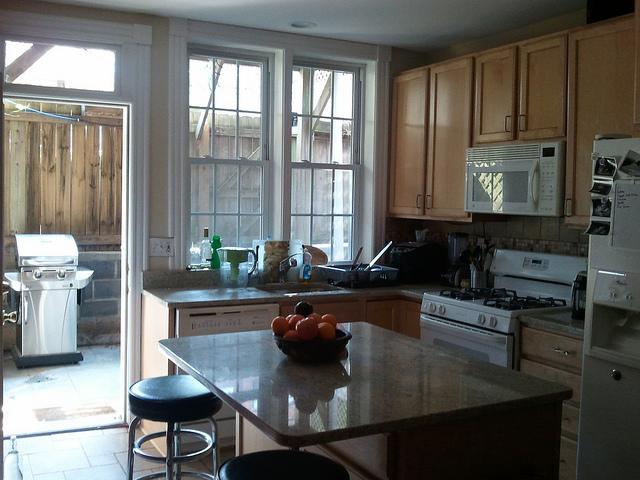Where is the stainless grill?
Be succinct. Outside. Is this a picture of the side of the house, or the back of the house?
Concise answer only. Back. What color is the fruit on the table?
Quick response, please. Orange. 